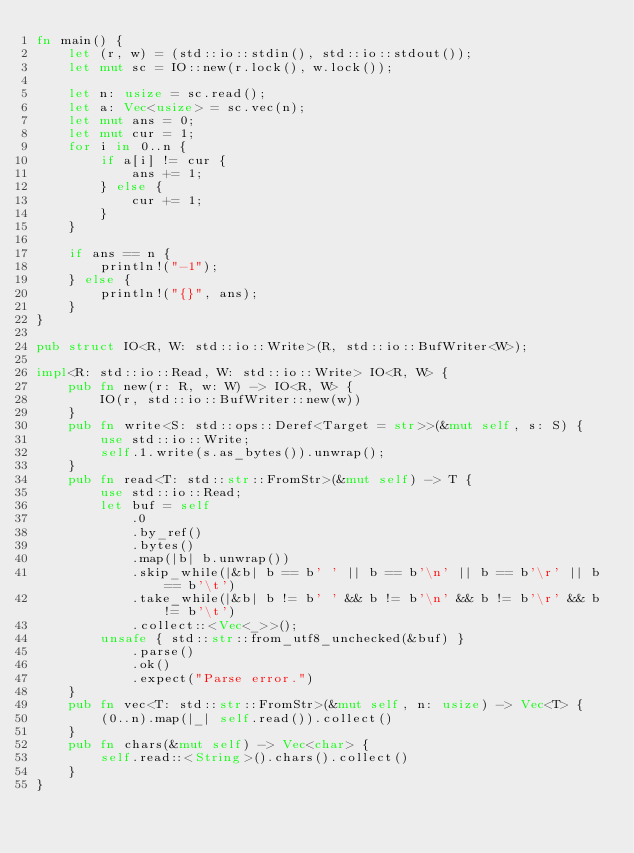<code> <loc_0><loc_0><loc_500><loc_500><_Rust_>fn main() {
    let (r, w) = (std::io::stdin(), std::io::stdout());
    let mut sc = IO::new(r.lock(), w.lock());

    let n: usize = sc.read();
    let a: Vec<usize> = sc.vec(n);
    let mut ans = 0;
    let mut cur = 1;
    for i in 0..n {
        if a[i] != cur {
            ans += 1;
        } else {
            cur += 1;
        }
    }

    if ans == n {
        println!("-1");
    } else {
        println!("{}", ans);
    }
}

pub struct IO<R, W: std::io::Write>(R, std::io::BufWriter<W>);

impl<R: std::io::Read, W: std::io::Write> IO<R, W> {
    pub fn new(r: R, w: W) -> IO<R, W> {
        IO(r, std::io::BufWriter::new(w))
    }
    pub fn write<S: std::ops::Deref<Target = str>>(&mut self, s: S) {
        use std::io::Write;
        self.1.write(s.as_bytes()).unwrap();
    }
    pub fn read<T: std::str::FromStr>(&mut self) -> T {
        use std::io::Read;
        let buf = self
            .0
            .by_ref()
            .bytes()
            .map(|b| b.unwrap())
            .skip_while(|&b| b == b' ' || b == b'\n' || b == b'\r' || b == b'\t')
            .take_while(|&b| b != b' ' && b != b'\n' && b != b'\r' && b != b'\t')
            .collect::<Vec<_>>();
        unsafe { std::str::from_utf8_unchecked(&buf) }
            .parse()
            .ok()
            .expect("Parse error.")
    }
    pub fn vec<T: std::str::FromStr>(&mut self, n: usize) -> Vec<T> {
        (0..n).map(|_| self.read()).collect()
    }
    pub fn chars(&mut self) -> Vec<char> {
        self.read::<String>().chars().collect()
    }
}
</code> 